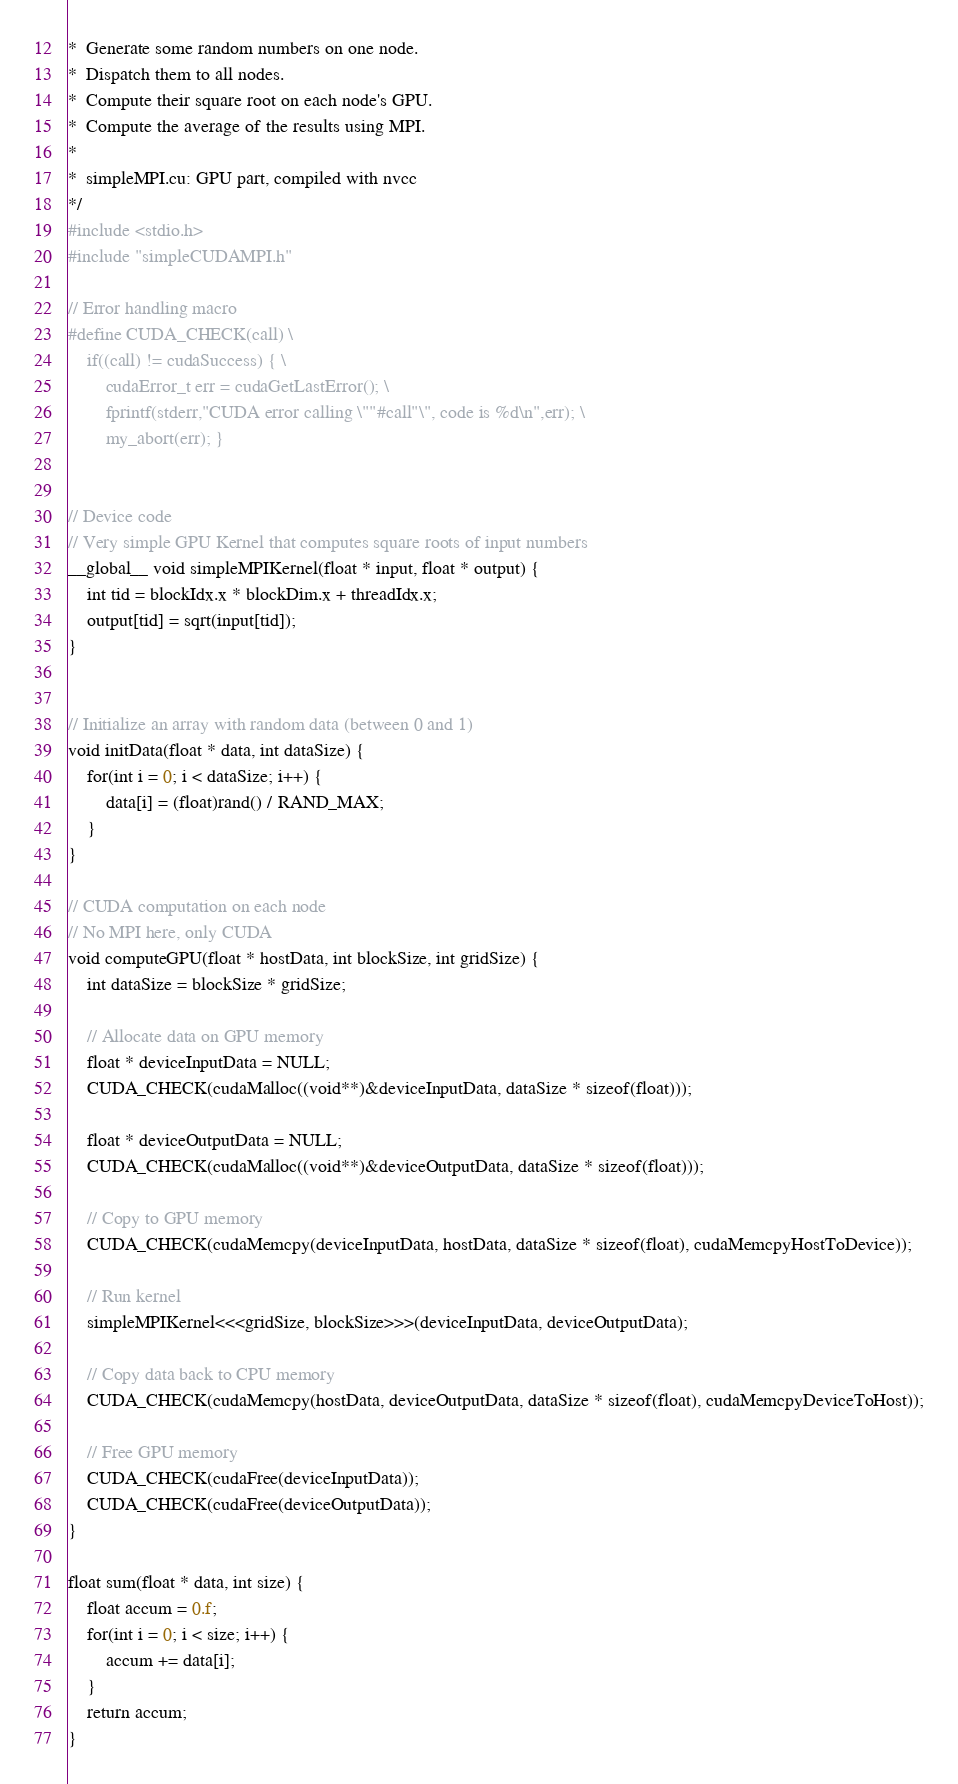Convert code to text. <code><loc_0><loc_0><loc_500><loc_500><_Cuda_>*  Generate some random numbers on one node.
*  Dispatch them to all nodes.
*  Compute their square root on each node's GPU.
*  Compute the average of the results using MPI.
*
*  simpleMPI.cu: GPU part, compiled with nvcc
*/
#include <stdio.h>
#include "simpleCUDAMPI.h"

// Error handling macro
#define CUDA_CHECK(call) \
    if((call) != cudaSuccess) { \
        cudaError_t err = cudaGetLastError(); \
        fprintf(stderr,"CUDA error calling \""#call"\", code is %d\n",err); \
        my_abort(err); }


// Device code
// Very simple GPU Kernel that computes square roots of input numbers
__global__ void simpleMPIKernel(float * input, float * output) {
    int tid = blockIdx.x * blockDim.x + threadIdx.x;
    output[tid] = sqrt(input[tid]);
}


// Initialize an array with random data (between 0 and 1)
void initData(float * data, int dataSize) {
    for(int i = 0; i < dataSize; i++) {
        data[i] = (float)rand() / RAND_MAX;
    }
}

// CUDA computation on each node
// No MPI here, only CUDA
void computeGPU(float * hostData, int blockSize, int gridSize) {
    int dataSize = blockSize * gridSize;
    
    // Allocate data on GPU memory
    float * deviceInputData = NULL;
    CUDA_CHECK(cudaMalloc((void**)&deviceInputData, dataSize * sizeof(float)));
    
    float * deviceOutputData = NULL;
    CUDA_CHECK(cudaMalloc((void**)&deviceOutputData, dataSize * sizeof(float)));
    
    // Copy to GPU memory
    CUDA_CHECK(cudaMemcpy(deviceInputData, hostData, dataSize * sizeof(float), cudaMemcpyHostToDevice));
    
    // Run kernel
    simpleMPIKernel<<<gridSize, blockSize>>>(deviceInputData, deviceOutputData);
    
    // Copy data back to CPU memory
    CUDA_CHECK(cudaMemcpy(hostData, deviceOutputData, dataSize * sizeof(float), cudaMemcpyDeviceToHost));
    
    // Free GPU memory
    CUDA_CHECK(cudaFree(deviceInputData));
    CUDA_CHECK(cudaFree(deviceOutputData));
}

float sum(float * data, int size) {
    float accum = 0.f;
    for(int i = 0; i < size; i++) {
        accum += data[i];
    }
    return accum;
}

</code> 